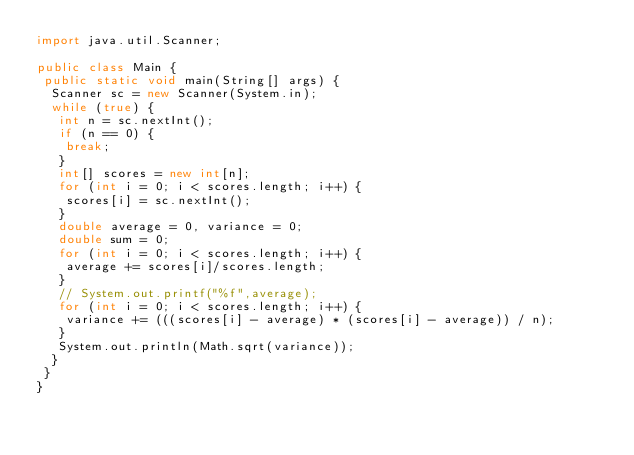<code> <loc_0><loc_0><loc_500><loc_500><_Java_>import java.util.Scanner;

public class Main {
 public static void main(String[] args) {
  Scanner sc = new Scanner(System.in);
  while (true) {
   int n = sc.nextInt();
   if (n == 0) {
    break;
   }
   int[] scores = new int[n];
   for (int i = 0; i < scores.length; i++) {
    scores[i] = sc.nextInt();
   }
   double average = 0, variance = 0;
   double sum = 0;
   for (int i = 0; i < scores.length; i++) {
    average += scores[i]/scores.length;
   }
   // System.out.printf("%f",average);
   for (int i = 0; i < scores.length; i++) {
    variance += (((scores[i] - average) * (scores[i] - average)) / n);
   }
   System.out.println(Math.sqrt(variance));
  }
 }
}</code> 